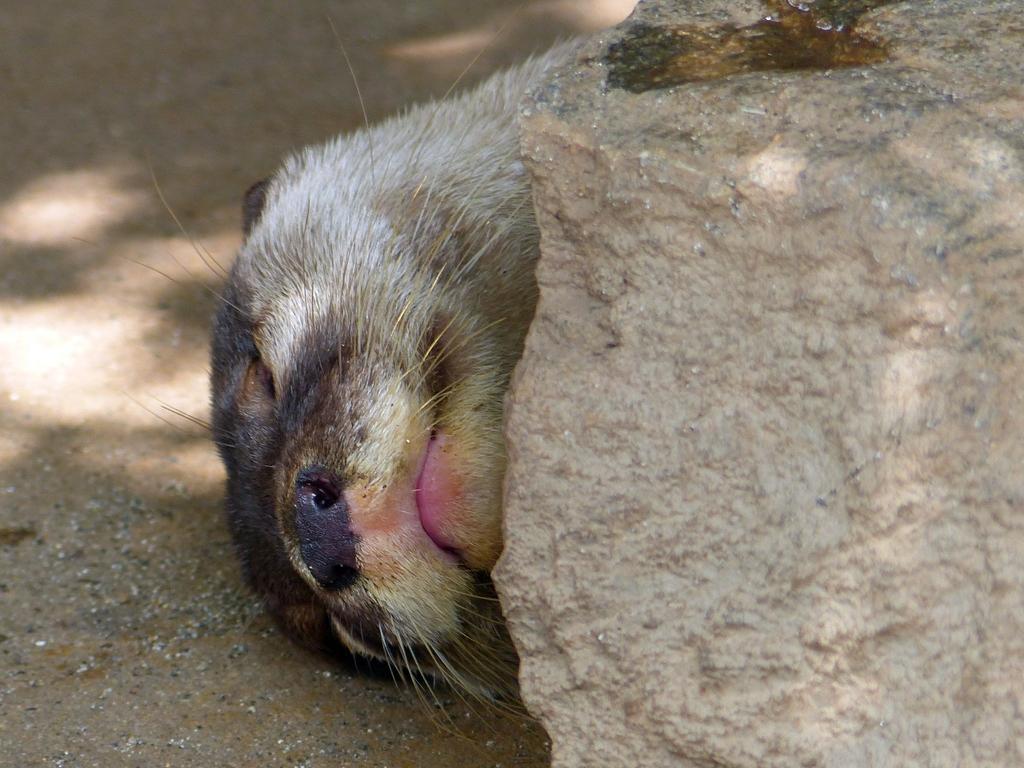Can you describe this image briefly? In this image we can see an animal on the ground beside a rock. 